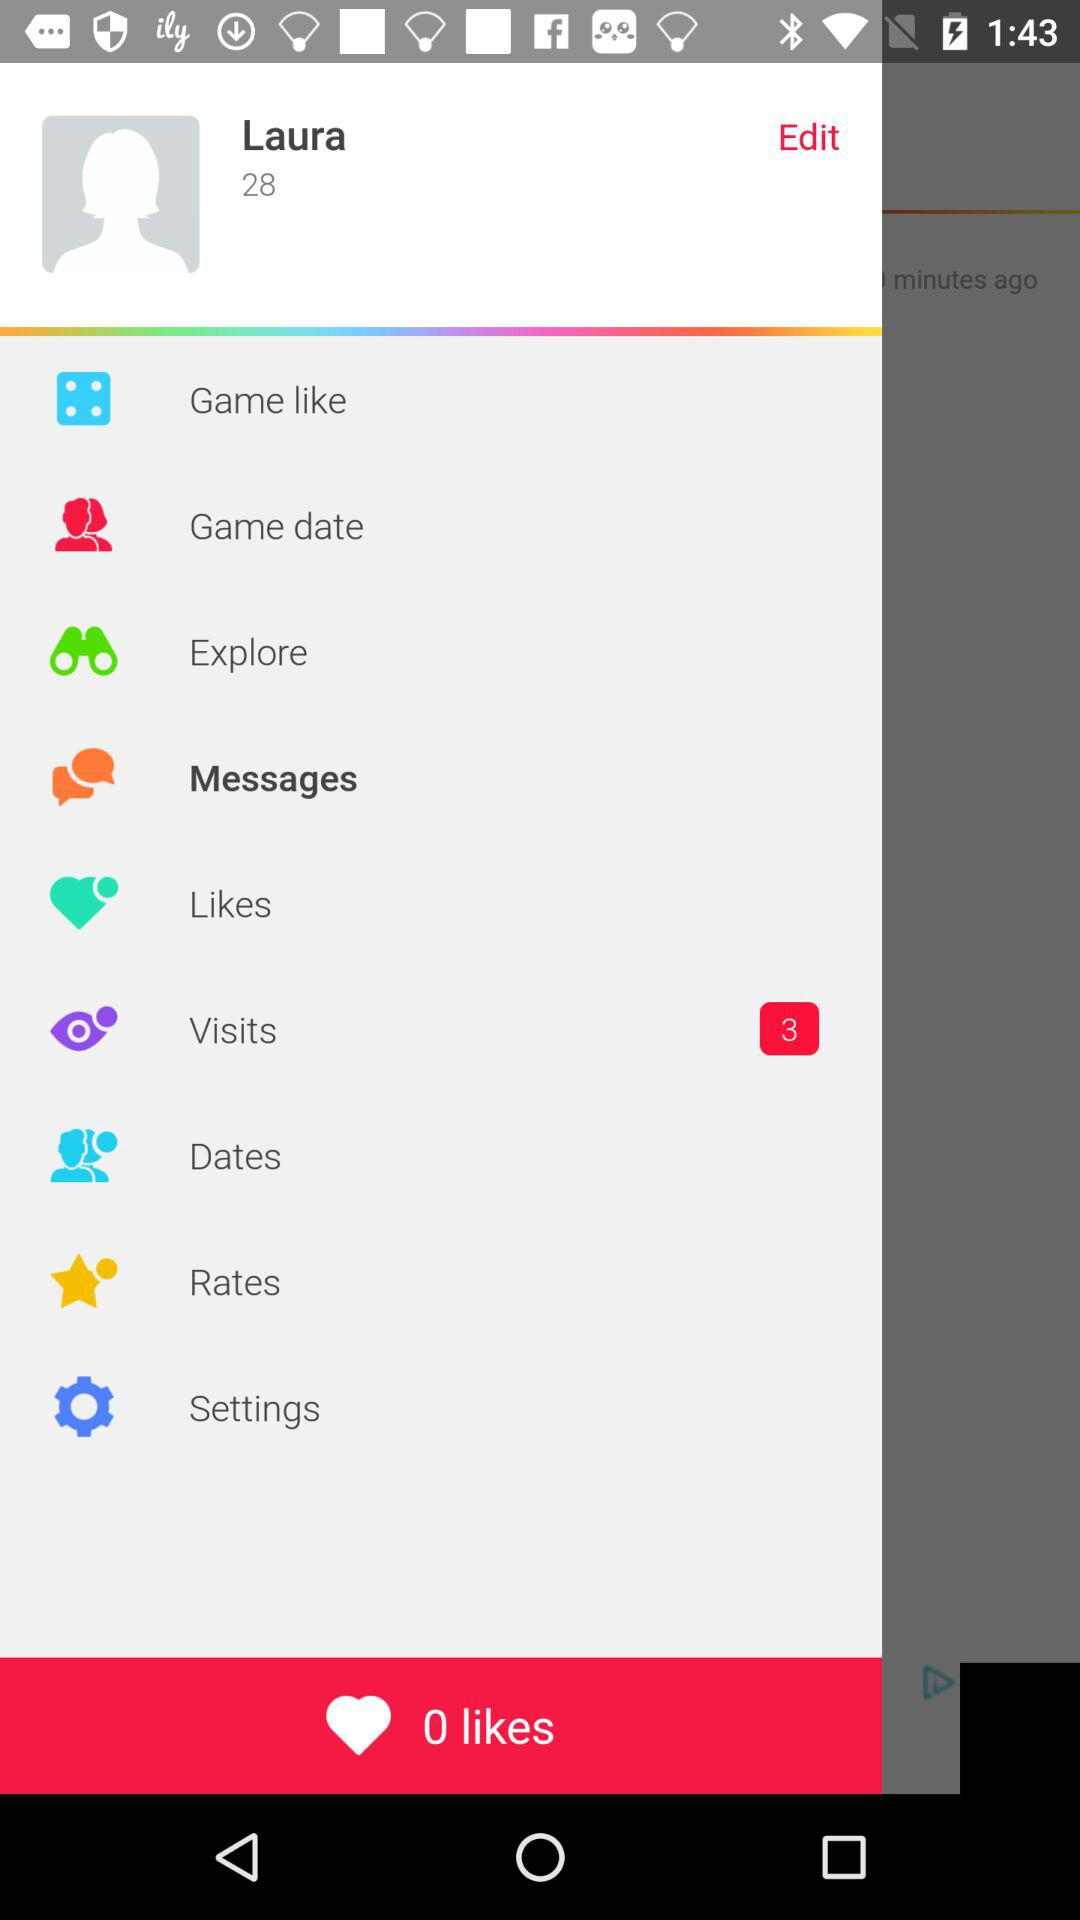What is the age of the person? The age of the person is 28. 